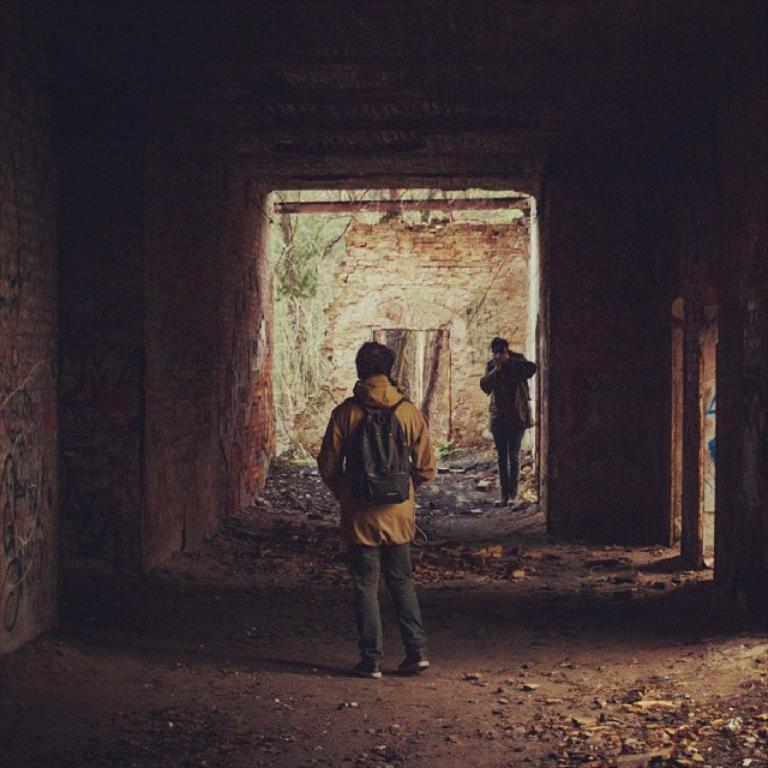How many people are in the image? There are people in the image, but the exact number is not specified. Can you describe the person in the middle of the image? The person in the middle of the image is wearing a bag. What can be seen in the background of the image? There are plants in the background of the image. What type of patch is sewn onto the person's clothing in the image? There is no mention of a patch on the person's clothing in the image. How much salt is visible on the person's hand in the image? There is no salt visible on the person's hand in the image. 